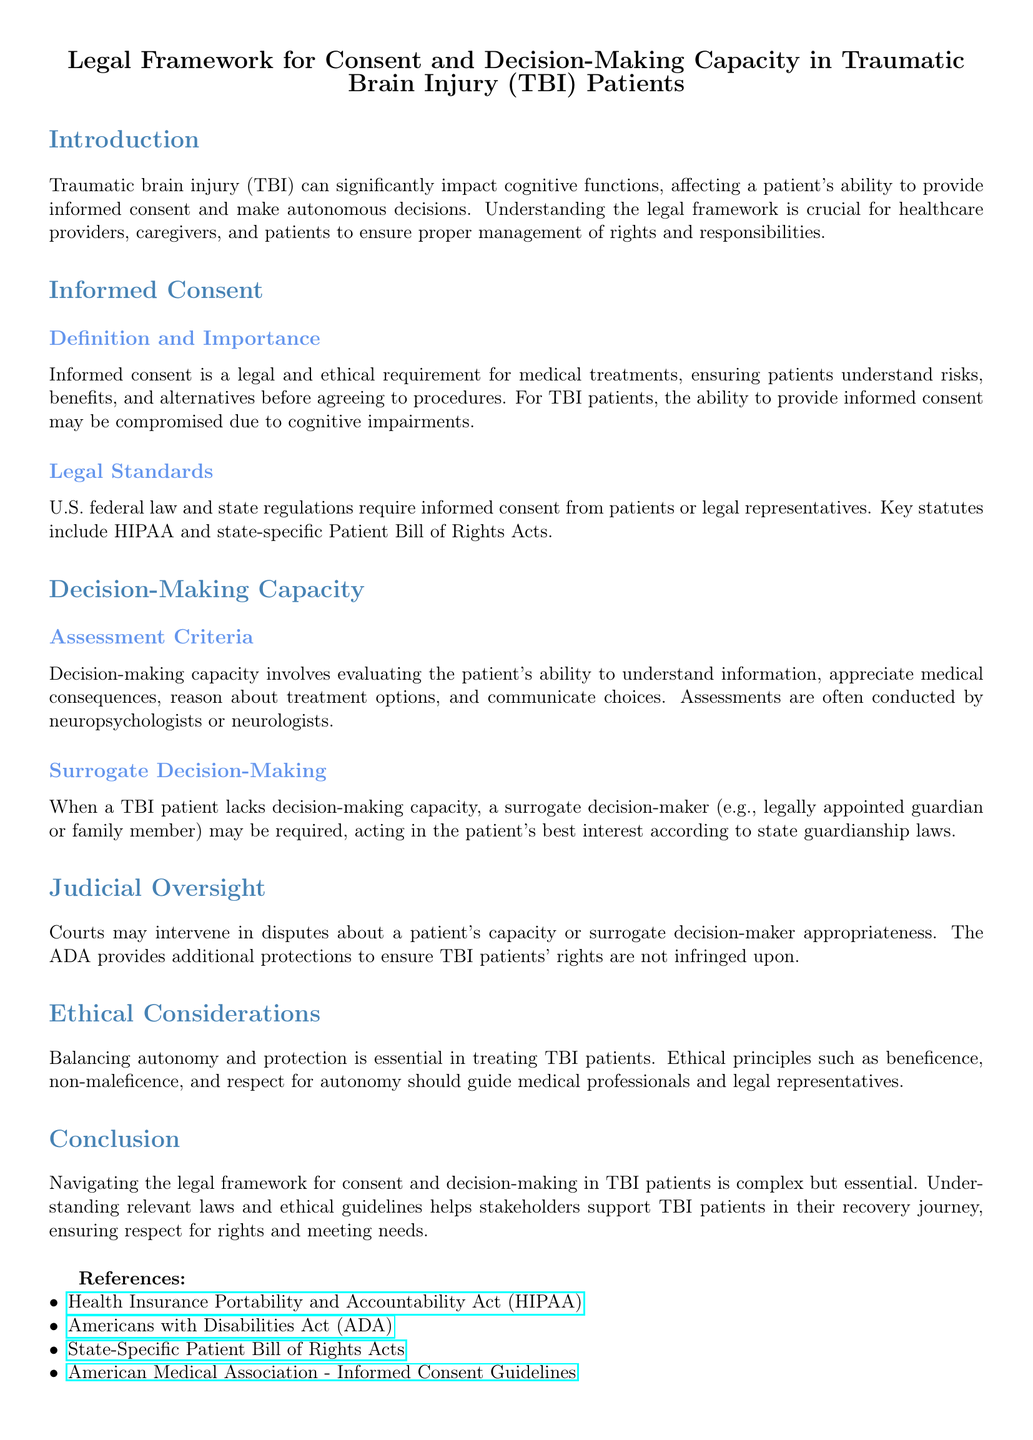What is the focus of the document? The document discusses the legal framework regarding consent and decision-making capacity in patients with traumatic brain injury (TBI).
Answer: Legal framework for consent and decision-making capacity in TBI patients What is required for informed consent according to the document? The document states that informed consent is a legal and ethical requirement ensuring patients understand risks, benefits, and alternatives before agreeing to treatments.
Answer: Understanding risks, benefits, and alternatives Who may assess decision-making capacity in TBI patients? The document indicates that assessments are often conducted by neuropsychologists or neurologists to evaluate decision-making capacity.
Answer: Neuropsychologists or neurologists What does ADA stand for? The document mentions ADA in the context of patient rights, which stands for the Americans with Disabilities Act.
Answer: Americans with Disabilities Act What principle is essential in treating TBI patients according to ethical considerations? The document highlights the importance of balancing autonomy and protection as an ethical consideration in treating TBI patients.
Answer: Balancing autonomy and protection What type of decision-maker is needed when a TBI patient lacks capacity? According to the document, a surrogate decision-maker is required when a TBI patient lacks decision-making capacity.
Answer: Surrogate decision-maker What document outlines the Patient Bill of Rights? The document refers to state-specific regulations that include the Patient Bill of Rights Acts.
Answer: State-specific Patient Bill of Rights Acts What action can courts take regarding TBI patients? The document states that courts may intervene in disputes about a patient’s capacity or surrogate decision-maker appropriateness.
Answer: Courts may intervene 